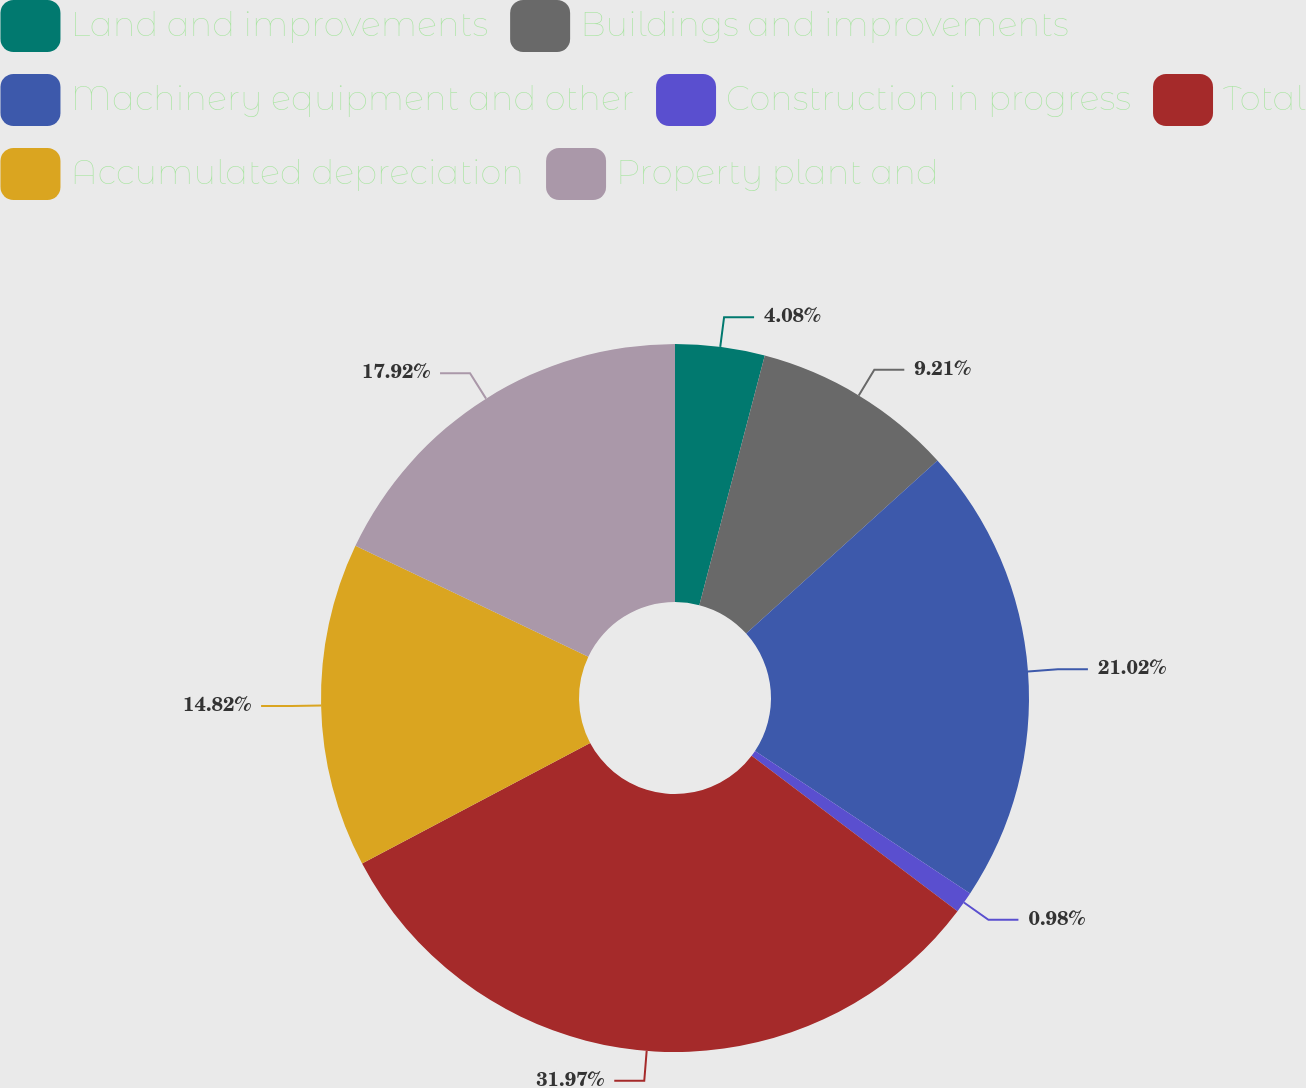<chart> <loc_0><loc_0><loc_500><loc_500><pie_chart><fcel>Land and improvements<fcel>Buildings and improvements<fcel>Machinery equipment and other<fcel>Construction in progress<fcel>Total<fcel>Accumulated depreciation<fcel>Property plant and<nl><fcel>4.08%<fcel>9.21%<fcel>21.02%<fcel>0.98%<fcel>31.96%<fcel>14.82%<fcel>17.92%<nl></chart> 